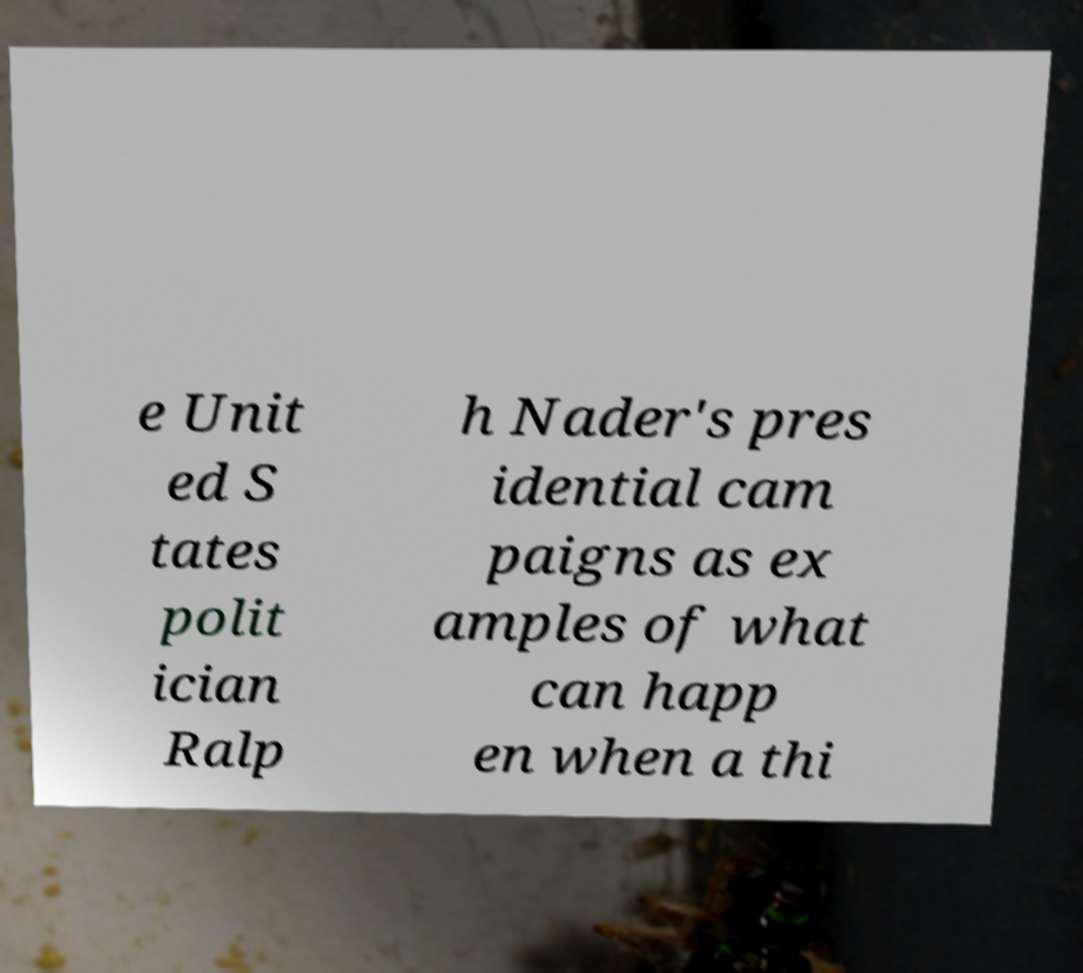Could you assist in decoding the text presented in this image and type it out clearly? e Unit ed S tates polit ician Ralp h Nader's pres idential cam paigns as ex amples of what can happ en when a thi 